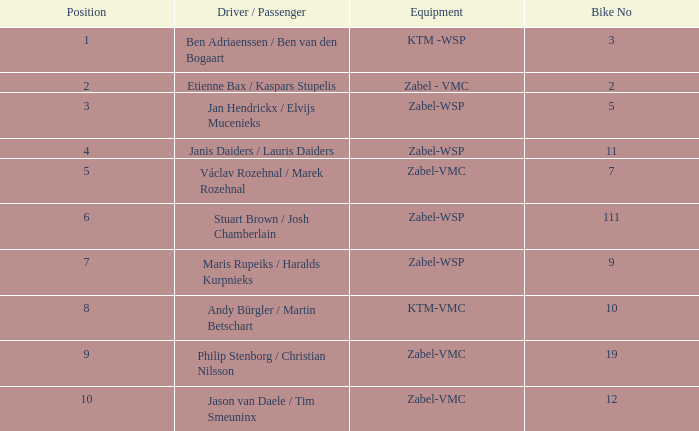What is the Equipment that has a Point bigger than 256, and a Position of 3? Zabel-WSP. 